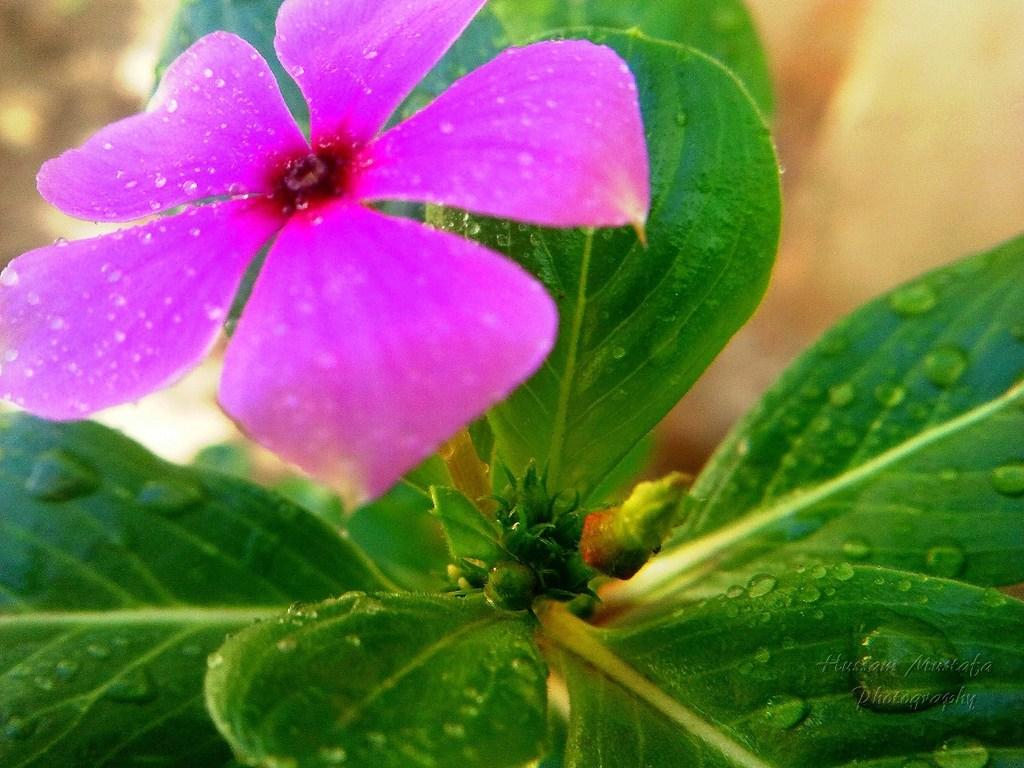What type of plant can be seen in the image? There is a flower in the image. What color is the flower? The flower is purple. What else is visible along with the flower? There are leaves associated with the flower. Can you describe the condition of the leaves? There are water drops on the leaves. What historical event is depicted in the image? There is no historical event depicted in the image; it features a purple flower with leaves and water drops. 